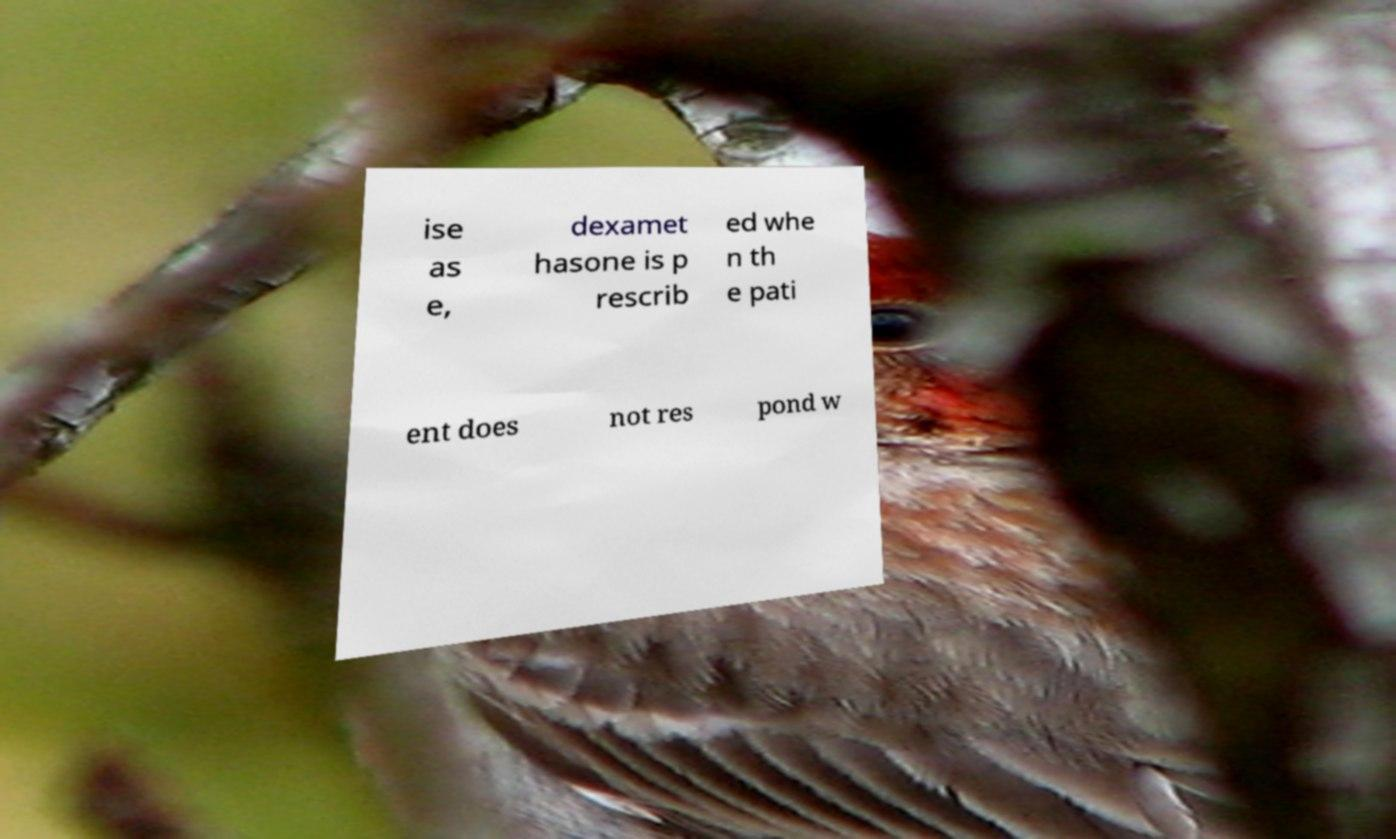Please identify and transcribe the text found in this image. ise as e, dexamet hasone is p rescrib ed whe n th e pati ent does not res pond w 